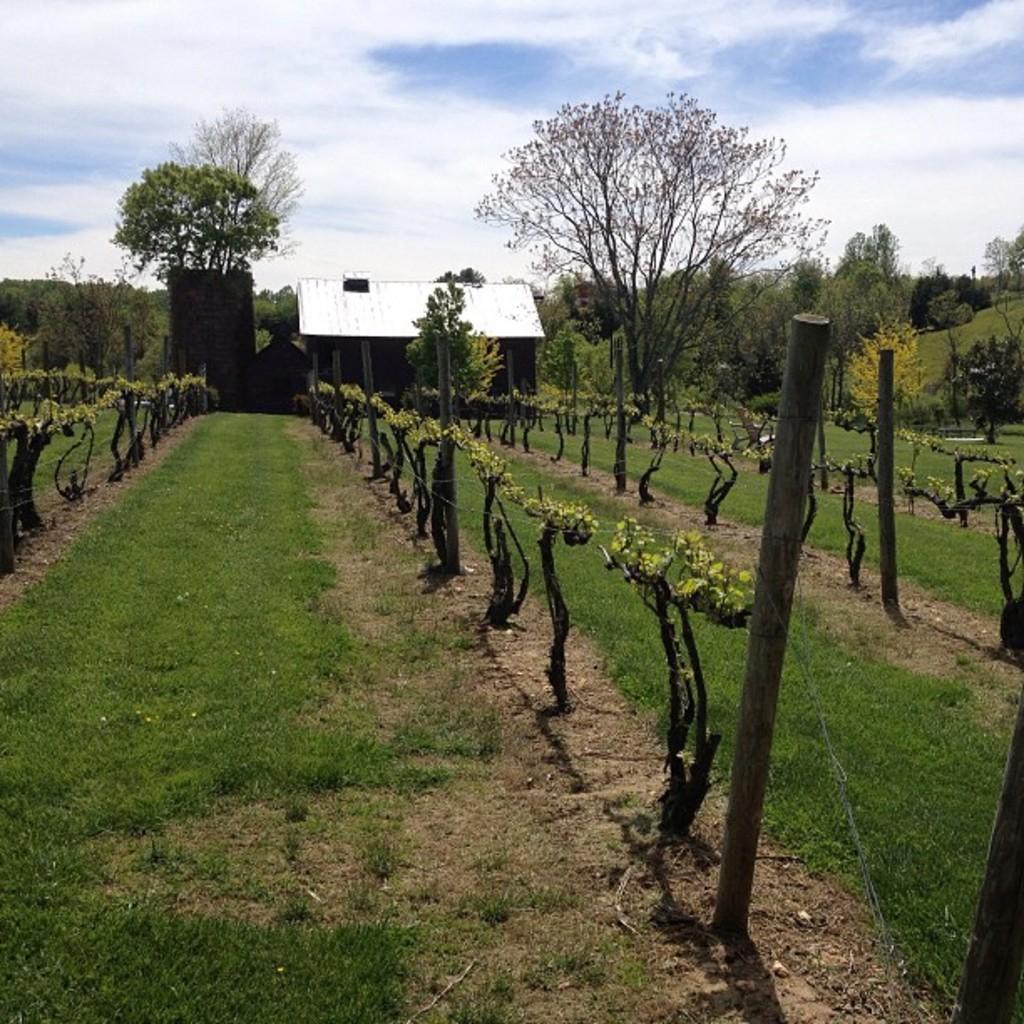How would you summarize this image in a sentence or two? In this picture, I can see trees and a house and few poles and grass on the ground and a blue cloudy Sky. 